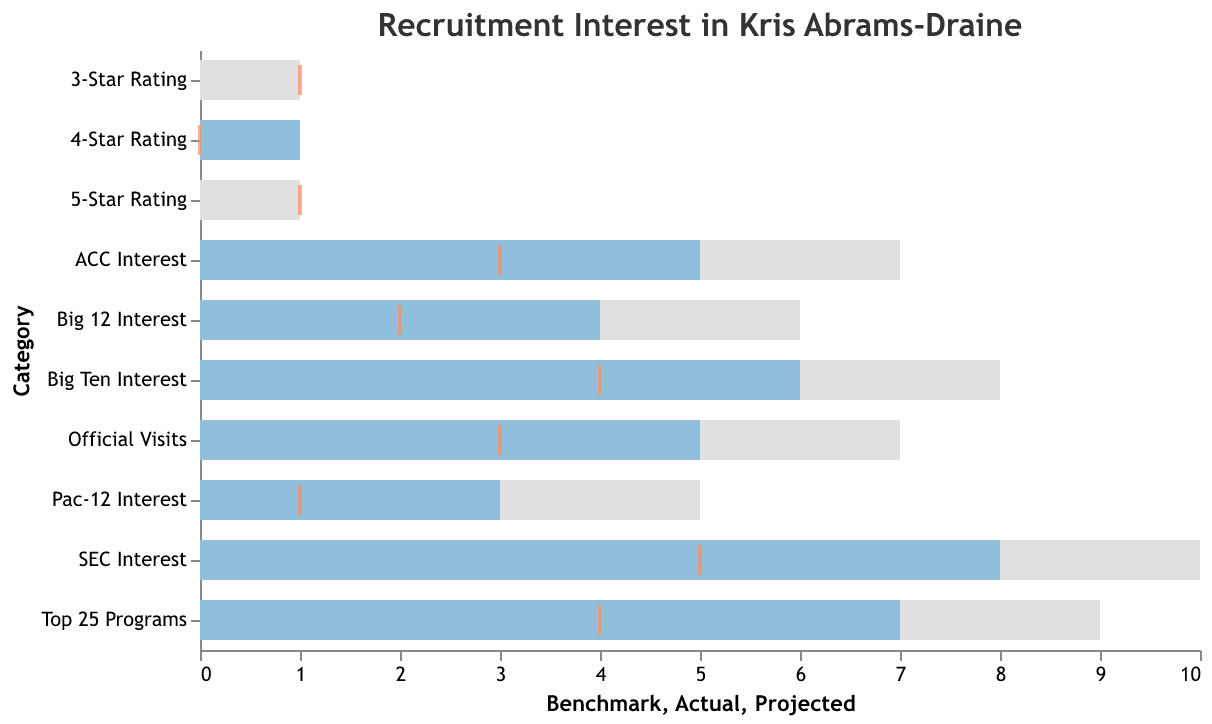What's the actual interest from SEC programs in Kris Abrams-Draine? The bar representing SEC Interest is marked at the value of 8 in the horizontal axis, indicating the actual interest level from SEC programs.
Answer: 8 How did the actual Big 12 Interest compare to the projected interest? The actual interest from Big 12 programs is 4, while the projected interest is indicated by a tick mark at 2. The actual interest is twice the projected interest.
Answer: Actual interest is 4, Projected interest is 2 Which category had the highest actual interest value? The "SEC Interest" category has the highest actual interest value with a bar extending to 8 on the horizontal axis.
Answer: SEC Interest What is the difference between the actual and projected interest from Top 25 Programs? The actual interest from Top 25 Programs is 7, and the projected interest is 4. The difference is calculated as 7 - 4.
Answer: 3 How far below the benchmark is the actual recruitment as a 5-star player? The benchmark for a 5-star rating is 1, while the actual value is 0. The difference is 1 - 0.
Answer: 1 What percentage of the benchmark was achieved in terms of ACC Interest? The actual ACC Interest is 5, and the benchmark is 7. The percentage achieved is (5/7) * 100%.
Answer: ~71.43% Among the star ratings (5-Star, 4-Star, 3-Star), which one met its projected value? The 4-Star rating has an actual value of 1, which matches its benchmark value of 1, unlike the other star ratings where actual values are different from projections.
Answer: 4-Star Rating Which category has the smallest gap between actual interest and benchmark? The "4-Star Rating" category has an actual value of 1 and a benchmark of 1, resulting in a gap of 0, which is the smallest.
Answer: 4-Star Rating Is the actual official visits figure closer to the benchmark or the projected value? The actual official visits figure is 5, the benchmark is 7, and the projected value is 3. The difference between actual and benchmark is 2, while the difference between actual and projected is 2 as well. Therefore, both are equally close, but given exact matches are rare, we'd acknowledge either.
Answer: Equally close 